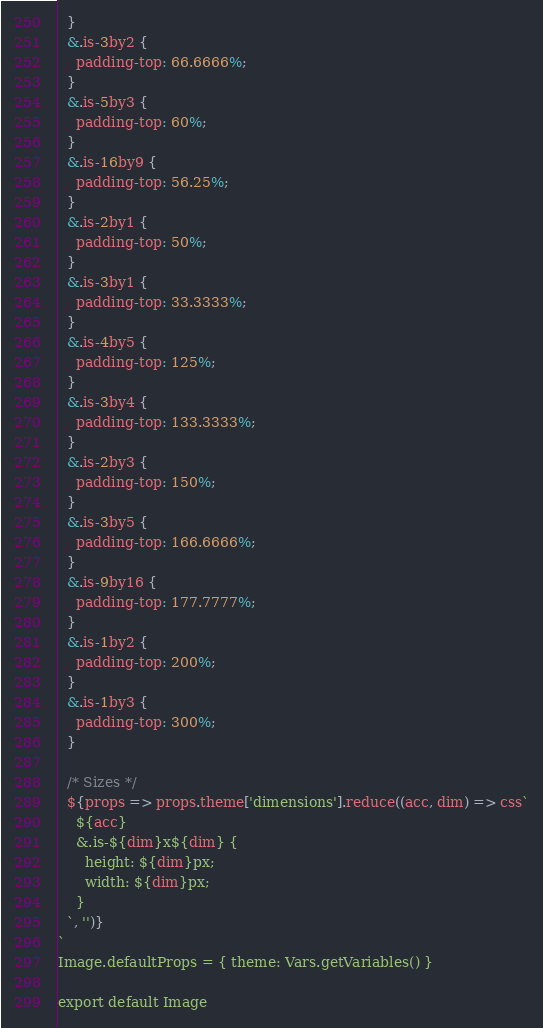<code> <loc_0><loc_0><loc_500><loc_500><_JavaScript_>  }
  &.is-3by2 {
    padding-top: 66.6666%;
  }
  &.is-5by3 {
    padding-top: 60%;
  }
  &.is-16by9 {
    padding-top: 56.25%;
  }
  &.is-2by1 {
    padding-top: 50%;
  }
  &.is-3by1 {
    padding-top: 33.3333%;
  }
  &.is-4by5 {
    padding-top: 125%;
  }
  &.is-3by4 {
    padding-top: 133.3333%;
  }
  &.is-2by3 {
    padding-top: 150%;
  }
  &.is-3by5 {
    padding-top: 166.6666%;
  }
  &.is-9by16 {
    padding-top: 177.7777%;
  }
  &.is-1by2 {
    padding-top: 200%;
  }
  &.is-1by3 {
    padding-top: 300%;
  }

  /* Sizes */
  ${props => props.theme['dimensions'].reduce((acc, dim) => css`
    ${acc}
    &.is-${dim}x${dim} {
      height: ${dim}px;
      width: ${dim}px;
    }
  `, '')}
`
Image.defaultProps = { theme: Vars.getVariables() }

export default Image
</code> 